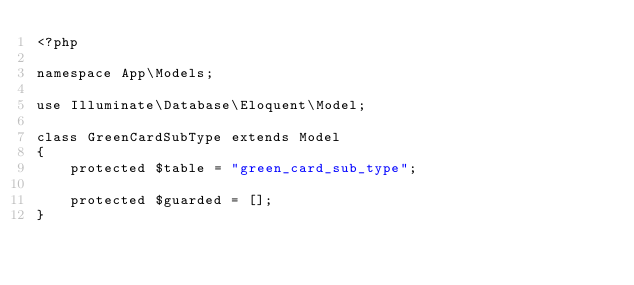<code> <loc_0><loc_0><loc_500><loc_500><_PHP_><?php

namespace App\Models;

use Illuminate\Database\Eloquent\Model;

class GreenCardSubType extends Model
{
    protected $table = "green_card_sub_type";

    protected $guarded = [];
}
</code> 